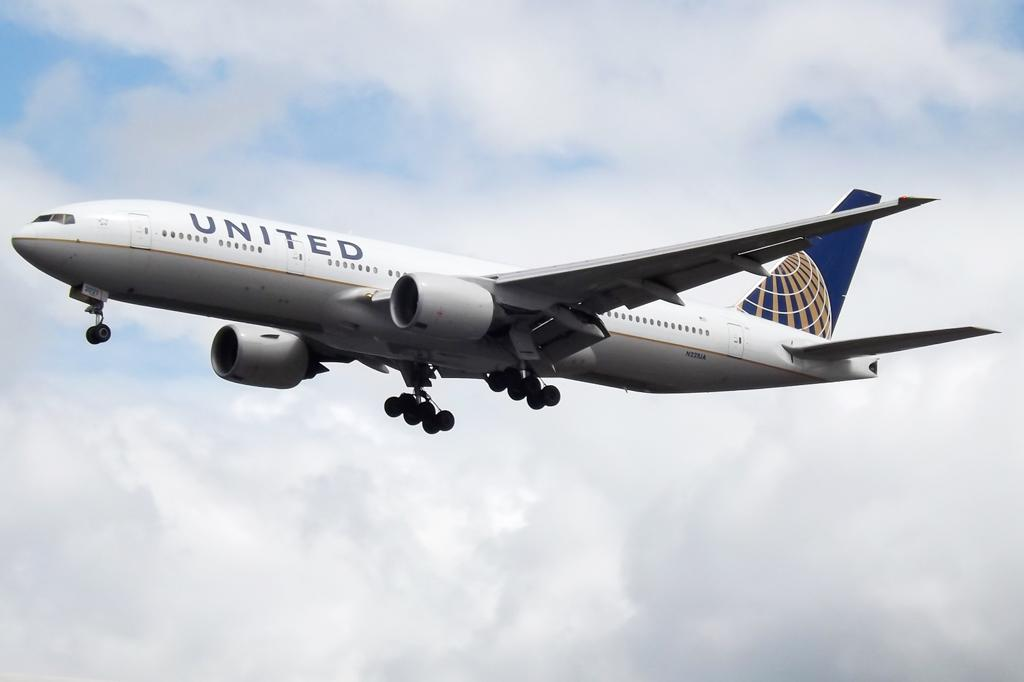<image>
Write a terse but informative summary of the picture. A United Airlines jet in mid flight with clouds behind it. 